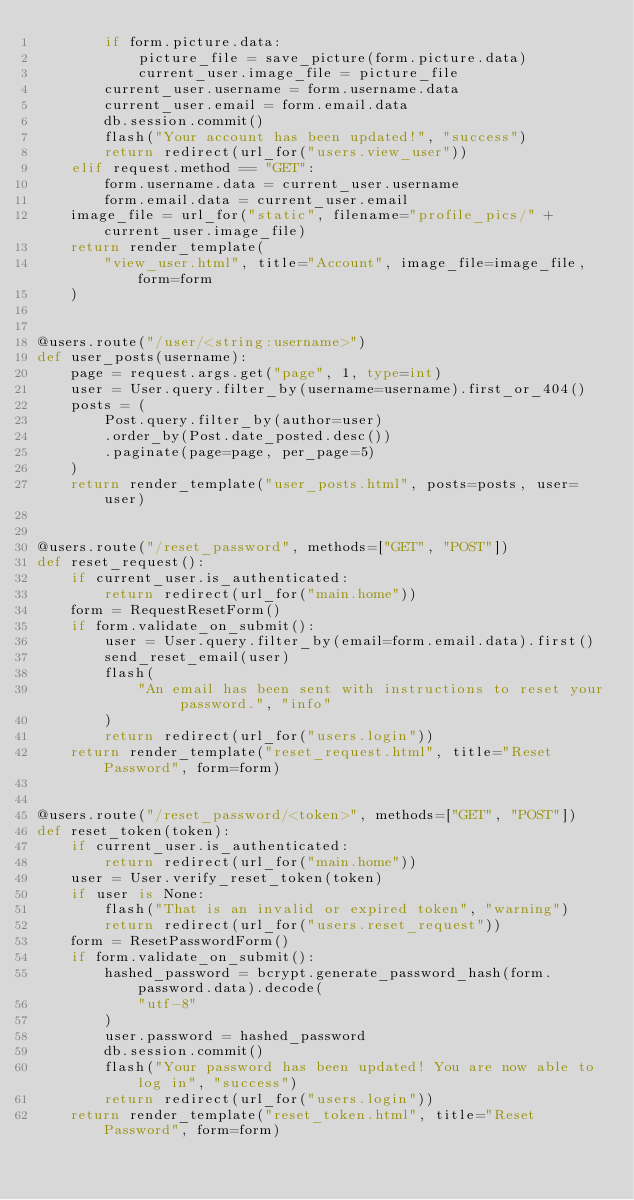Convert code to text. <code><loc_0><loc_0><loc_500><loc_500><_Python_>        if form.picture.data:
            picture_file = save_picture(form.picture.data)
            current_user.image_file = picture_file
        current_user.username = form.username.data
        current_user.email = form.email.data
        db.session.commit()
        flash("Your account has been updated!", "success")
        return redirect(url_for("users.view_user"))
    elif request.method == "GET":
        form.username.data = current_user.username
        form.email.data = current_user.email
    image_file = url_for("static", filename="profile_pics/" + current_user.image_file)
    return render_template(
        "view_user.html", title="Account", image_file=image_file, form=form
    )


@users.route("/user/<string:username>")
def user_posts(username):
    page = request.args.get("page", 1, type=int)
    user = User.query.filter_by(username=username).first_or_404()
    posts = (
        Post.query.filter_by(author=user)
        .order_by(Post.date_posted.desc())
        .paginate(page=page, per_page=5)
    )
    return render_template("user_posts.html", posts=posts, user=user)


@users.route("/reset_password", methods=["GET", "POST"])
def reset_request():
    if current_user.is_authenticated:
        return redirect(url_for("main.home"))
    form = RequestResetForm()
    if form.validate_on_submit():
        user = User.query.filter_by(email=form.email.data).first()
        send_reset_email(user)
        flash(
            "An email has been sent with instructions to reset your password.", "info"
        )
        return redirect(url_for("users.login"))
    return render_template("reset_request.html", title="Reset Password", form=form)


@users.route("/reset_password/<token>", methods=["GET", "POST"])
def reset_token(token):
    if current_user.is_authenticated:
        return redirect(url_for("main.home"))
    user = User.verify_reset_token(token)
    if user is None:
        flash("That is an invalid or expired token", "warning")
        return redirect(url_for("users.reset_request"))
    form = ResetPasswordForm()
    if form.validate_on_submit():
        hashed_password = bcrypt.generate_password_hash(form.password.data).decode(
            "utf-8"
        )
        user.password = hashed_password
        db.session.commit()
        flash("Your password has been updated! You are now able to log in", "success")
        return redirect(url_for("users.login"))
    return render_template("reset_token.html", title="Reset Password", form=form)
</code> 